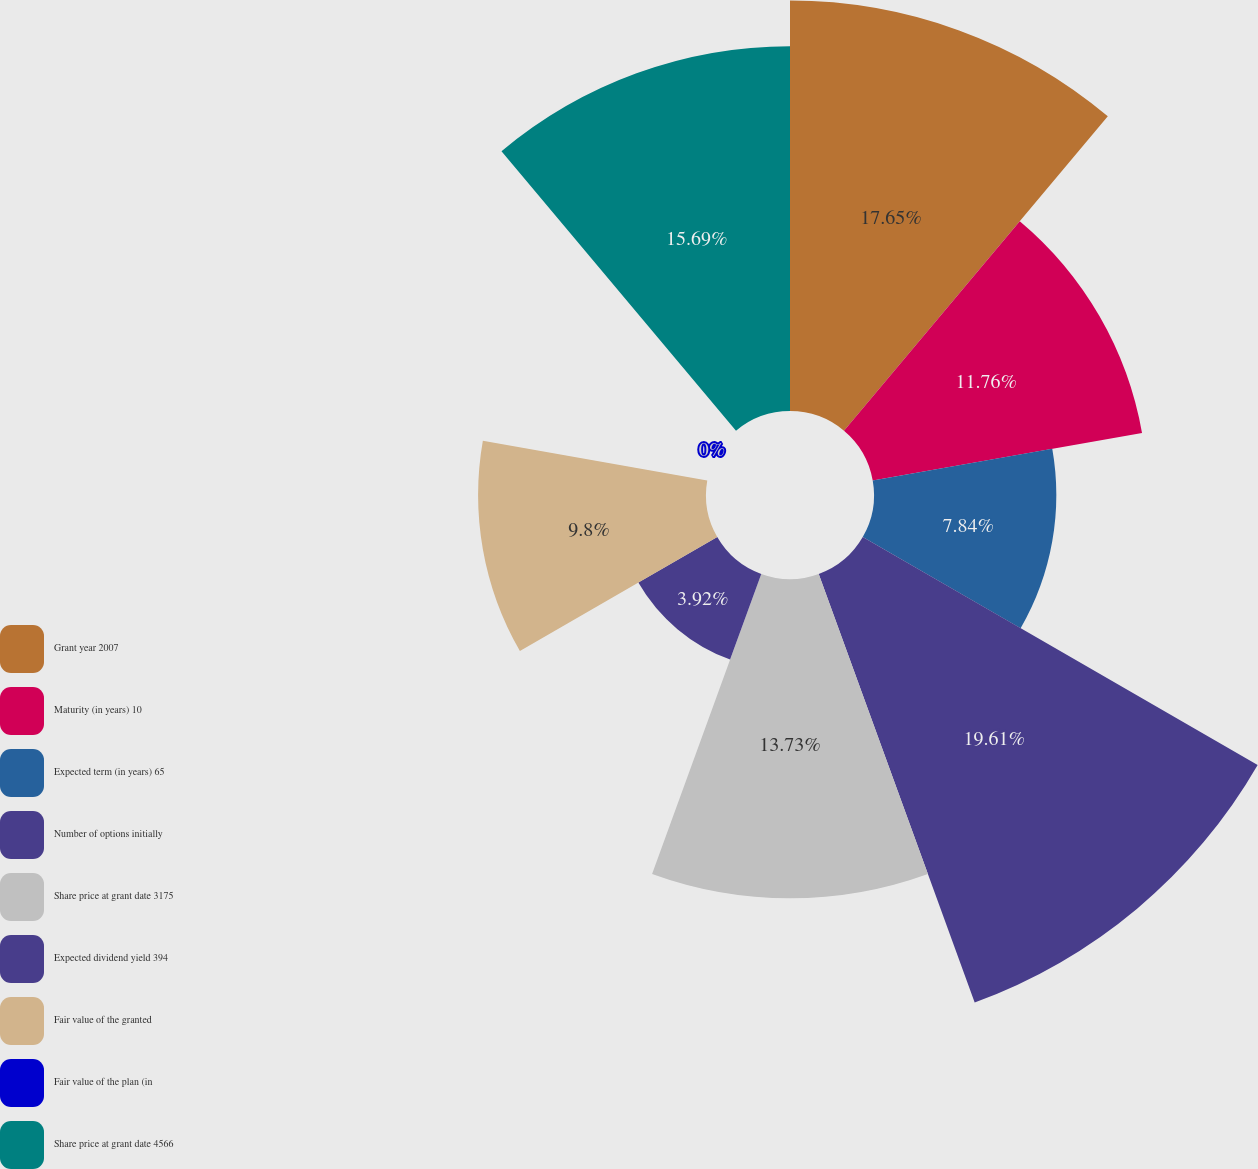Convert chart to OTSL. <chart><loc_0><loc_0><loc_500><loc_500><pie_chart><fcel>Grant year 2007<fcel>Maturity (in years) 10<fcel>Expected term (in years) 65<fcel>Number of options initially<fcel>Share price at grant date 3175<fcel>Expected dividend yield 394<fcel>Fair value of the granted<fcel>Fair value of the plan (in<fcel>Share price at grant date 4566<nl><fcel>17.65%<fcel>11.76%<fcel>7.84%<fcel>19.61%<fcel>13.73%<fcel>3.92%<fcel>9.8%<fcel>0.0%<fcel>15.69%<nl></chart> 